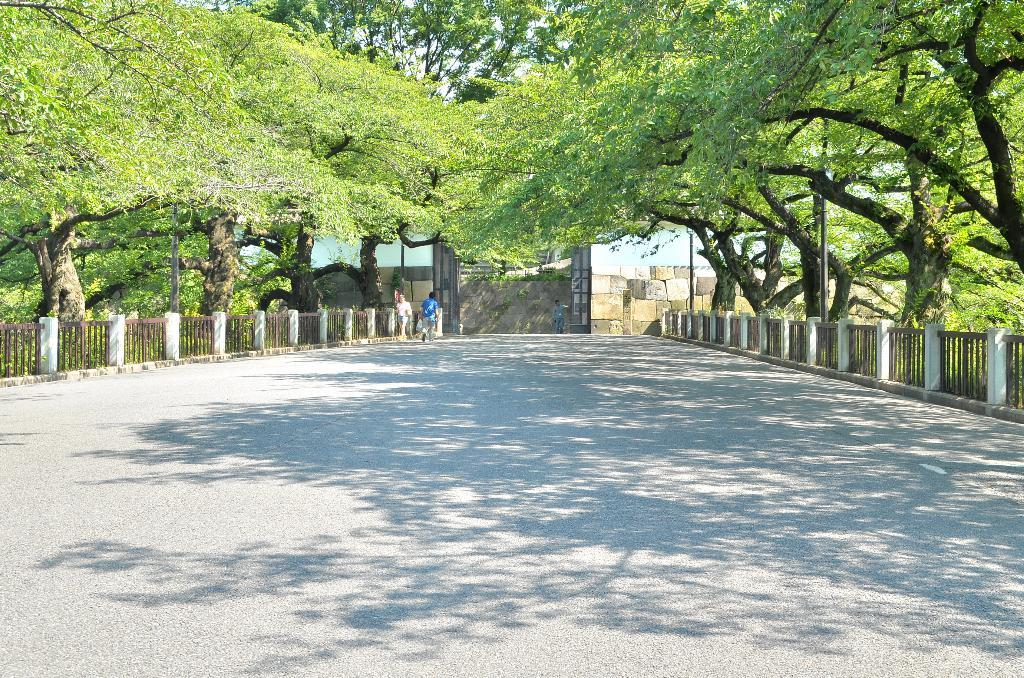What is the main feature of the image? There is a road in the image. What is the person in the image doing? A person is walking on the road. What can be seen on both sides of the road? There are trees on either side of the road. What type of branch is the person using to push the cart in the image? There is no branch or cart present in the image; it only features a road and a person walking. 